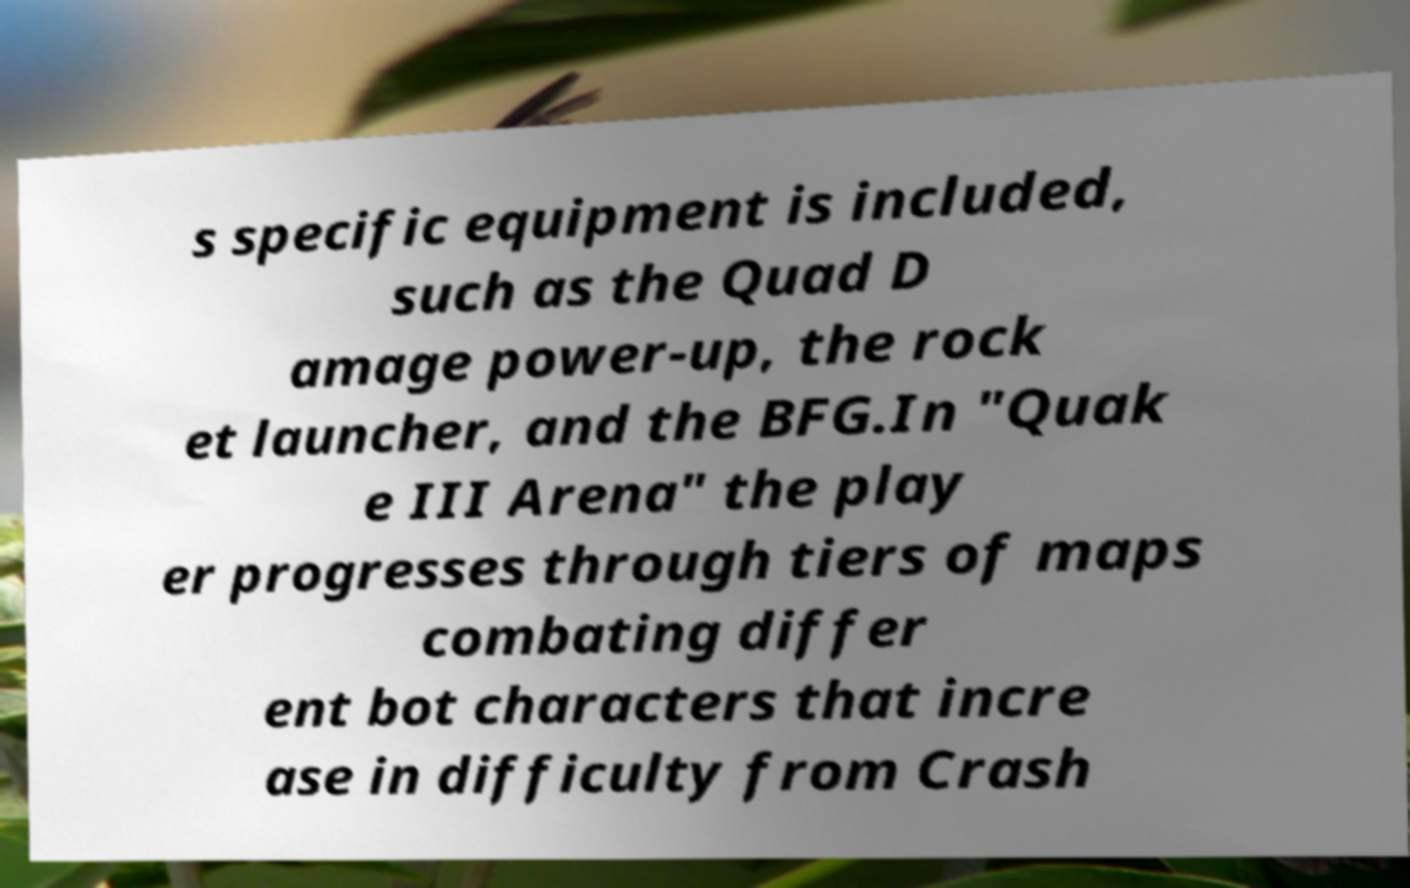For documentation purposes, I need the text within this image transcribed. Could you provide that? s specific equipment is included, such as the Quad D amage power-up, the rock et launcher, and the BFG.In "Quak e III Arena" the play er progresses through tiers of maps combating differ ent bot characters that incre ase in difficulty from Crash 